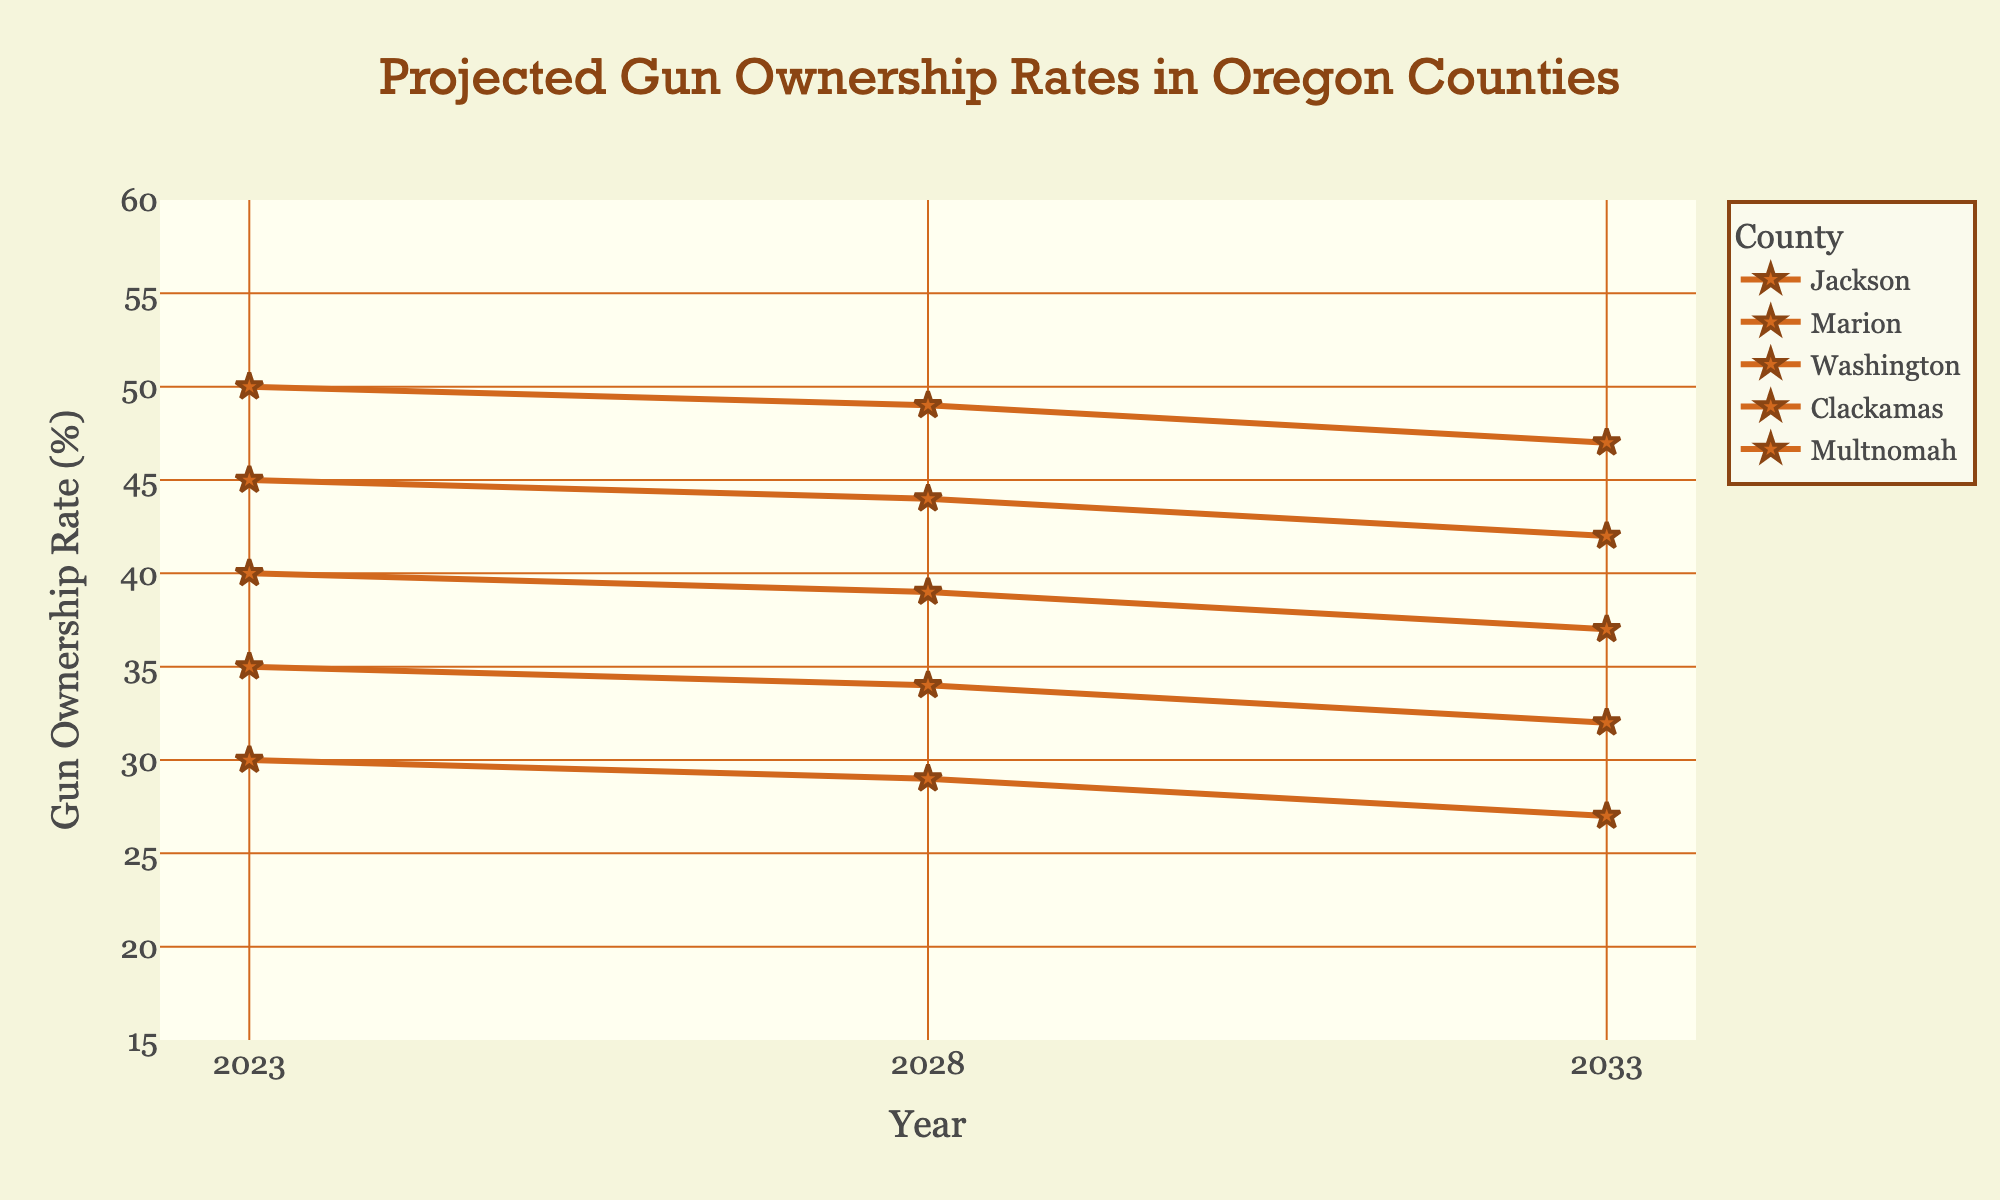What's the title of the chart? The title is found at the top center of the chart. It provides the main subject of the chart.
Answer: Projected Gun Ownership Rates in Oregon Counties What are the years displayed on the x-axis? The x-axis represents the timeline. The tick marks and labels show the specific years.
Answer: 2023, 2028, 2033 In which county is the projected mid-range gun ownership rate the lowest in 2033? Look for the county with the lowest "Mid" value in 2033.
Answer: Multnomah What is the range of projected gun ownership rates in Clackamas County for 2028? The range is given by the difference between the highest and lowest projected rates for Clackamas in 2028.
Answer: 33 to 45 Which county shows a decreasing trend in the projected mid-range gun ownership rate from 2023 to 2033? Compare the "Mid" values for each county across the years. Look for a consistent decrease from 2023 to 2033.
Answer: Multnomah How does the projected gun ownership rate in Jackson County in 2023 compare to that in Marion County? Check the 2023 values for Jackson and Marion counties. Compare their "Mid" values.
Answer: Jackson is higher Between 2023 and 2033, which county has the minimal change in the projected mid-range gun ownership rate? Calculate the change in "Mid" values from 2023 to 2033 for each county. Identify the smallest change.
Answer: Washington What is the average projected mid-range gun ownership rate across all counties in 2028? Add the "Mid" values for all counties in 2028 and divide by the number of counties.
Answer: (29 + 39 + 34 + 44 + 49) / 5 = 39 Which county has the widest range of projected gun ownership rates in 2033? For each county in 2033, calculate the difference between "High" and "Low". Select the maximum difference.
Answer: Jackson 